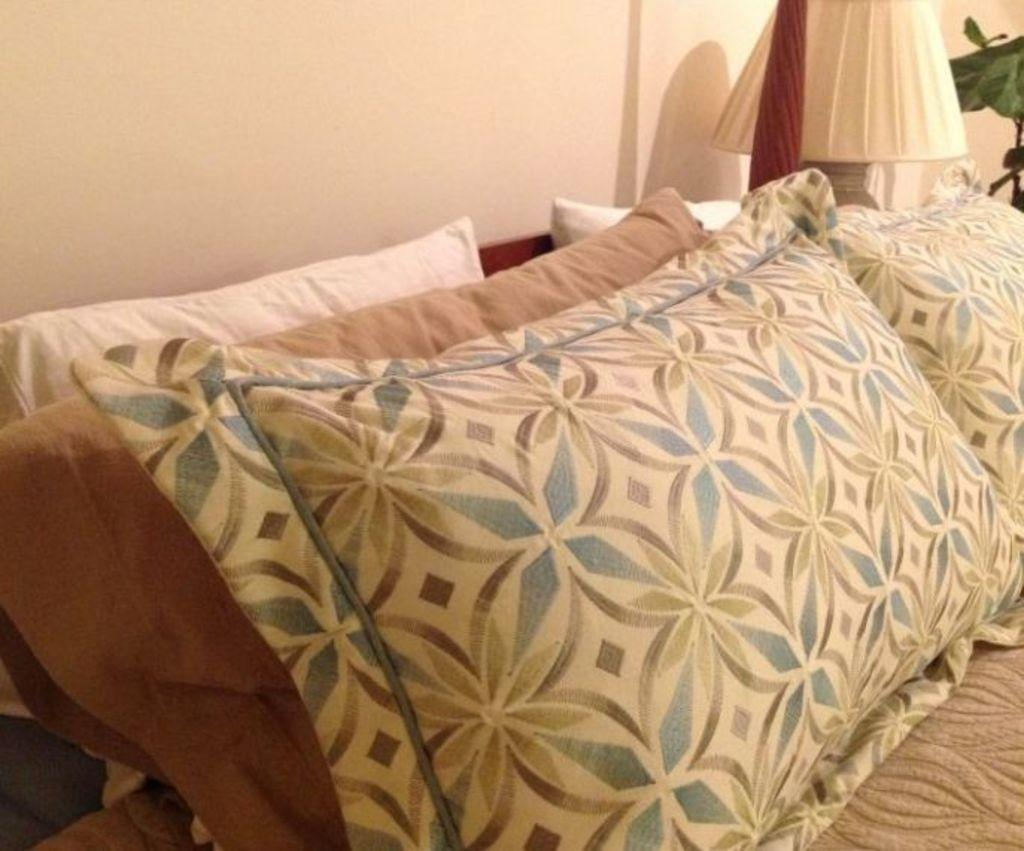What type of objects can be seen in the image? There are pillows in the image. Can you describe the appearance of the pillows? The pillows are white, brown, and have designs on them. What is the background of the image? There is a wall in the image. Are there any other objects visible in the image? Yes, there is a lamp and a plant in the image. What type of beast can be seen in the image? There is no beast present in the image; it features pillows, a wall, a lamp, and a plant. What type of flesh is visible on the pillows in the image? There is no flesh visible on the pillows in the image; they are made of fabric and have designs on them. 